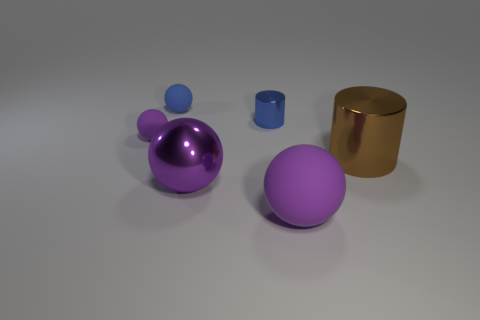Subtract all purple spheres. How many were subtracted if there are1purple spheres left? 2 Subtract all blue spheres. How many spheres are left? 3 Subtract all blue balls. How many balls are left? 3 Add 2 tiny cyan spheres. How many objects exist? 8 Subtract all spheres. How many objects are left? 2 Subtract 1 blue cylinders. How many objects are left? 5 Subtract 2 spheres. How many spheres are left? 2 Subtract all yellow balls. Subtract all gray cylinders. How many balls are left? 4 Subtract all cyan blocks. How many green cylinders are left? 0 Subtract all large purple balls. Subtract all large shiny balls. How many objects are left? 3 